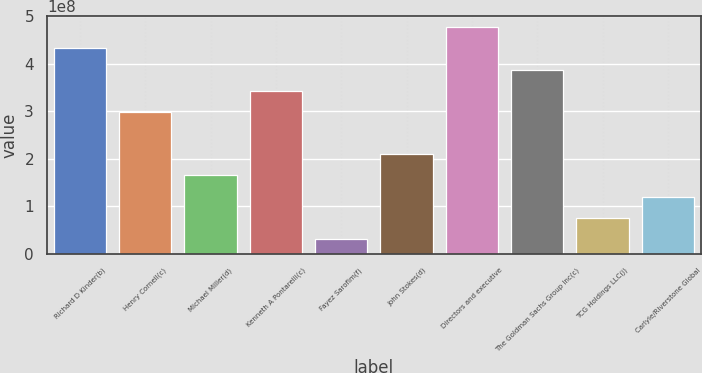Convert chart to OTSL. <chart><loc_0><loc_0><loc_500><loc_500><bar_chart><fcel>Richard D Kinder(b)<fcel>Henry Cornell(c)<fcel>Michael Miller(d)<fcel>Kenneth A Pontarelli(c)<fcel>Fayez Sarofim(f)<fcel>John Stokes(d)<fcel>Directors and executive<fcel>The Goldman Sachs Group Inc(c)<fcel>TCG Holdings LLC(j)<fcel>Carlyle/Riverstone Global<nl><fcel>4.31907e+08<fcel>2.98331e+08<fcel>1.64755e+08<fcel>3.42856e+08<fcel>3.11783e+07<fcel>2.0928e+08<fcel>4.76433e+08<fcel>3.87382e+08<fcel>7.57037e+07<fcel>1.20229e+08<nl></chart> 